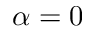<formula> <loc_0><loc_0><loc_500><loc_500>\alpha = 0</formula> 